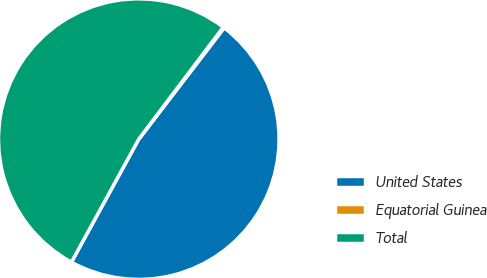Convert chart to OTSL. <chart><loc_0><loc_0><loc_500><loc_500><pie_chart><fcel>United States<fcel>Equatorial Guinea<fcel>Total<nl><fcel>47.56%<fcel>0.13%<fcel>52.32%<nl></chart> 